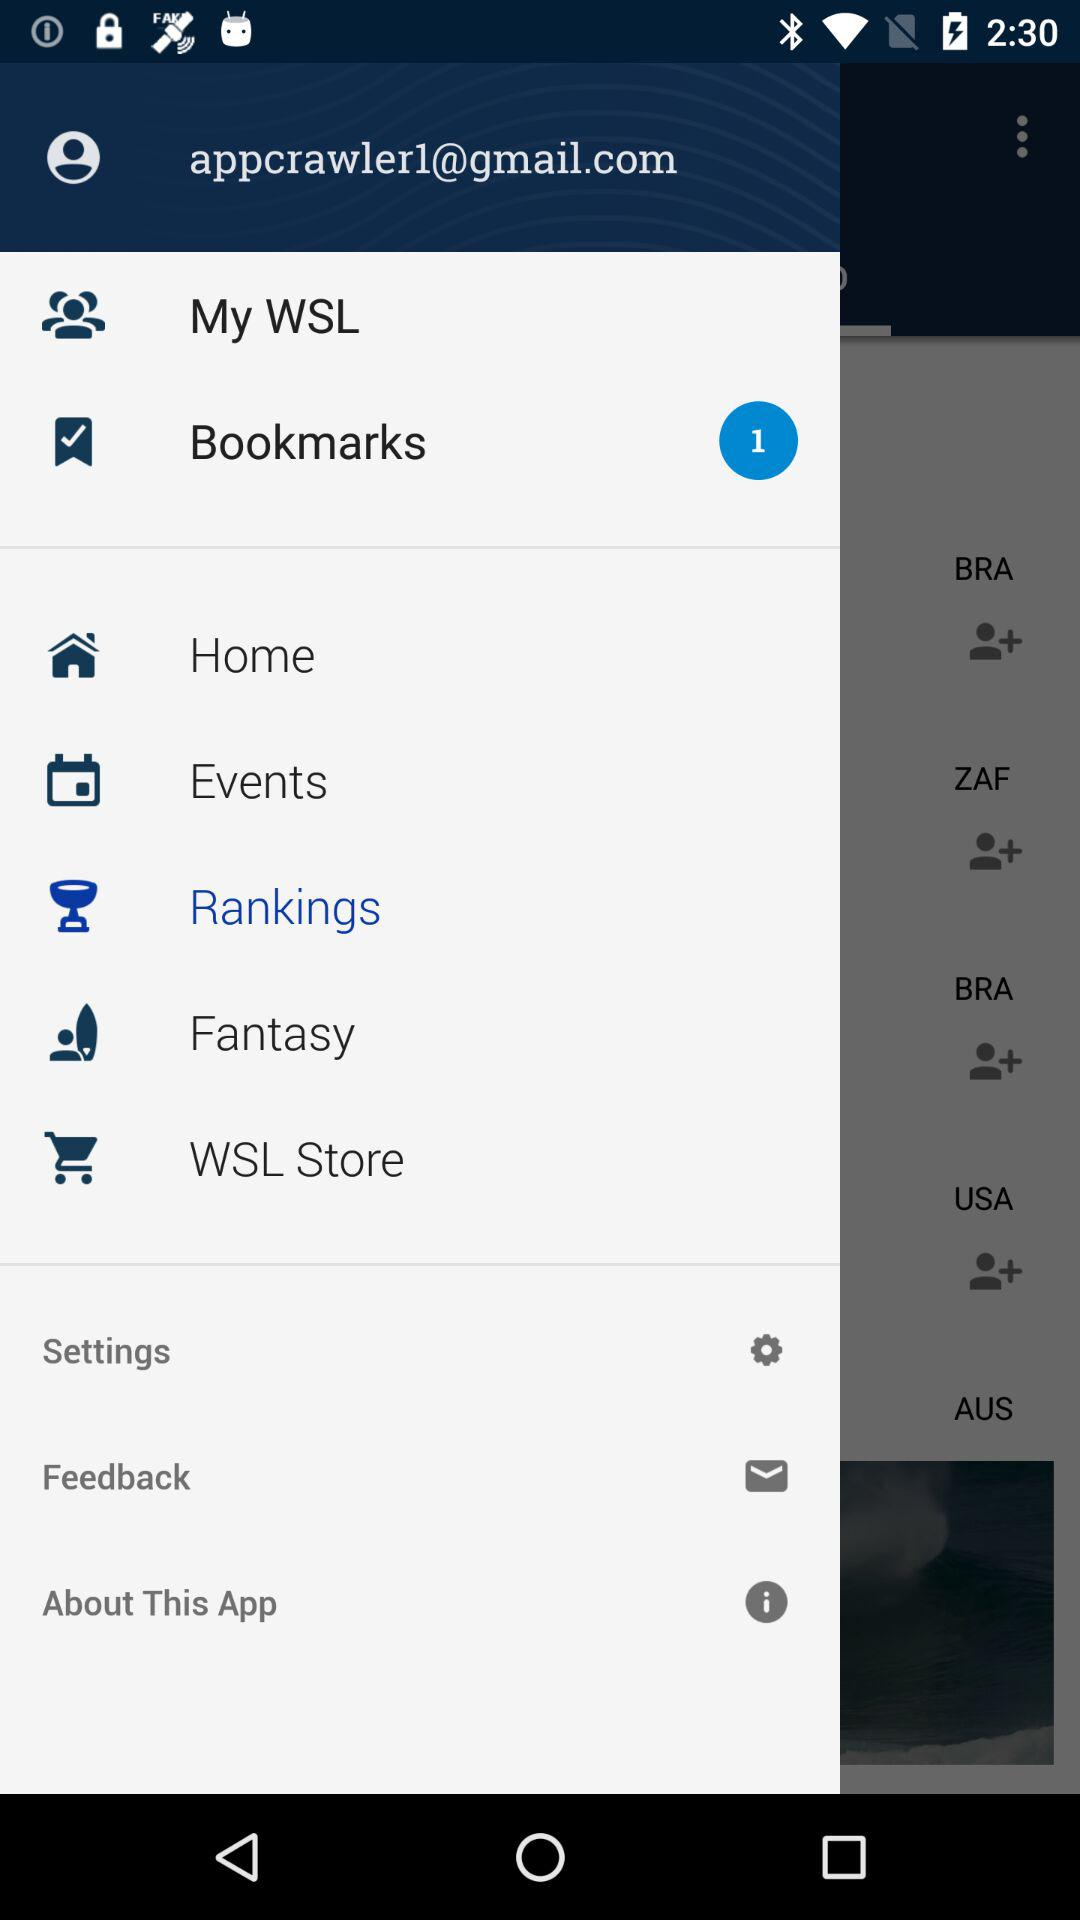Which item is selected in the menu? The selected item in the menu is "Rankings". 